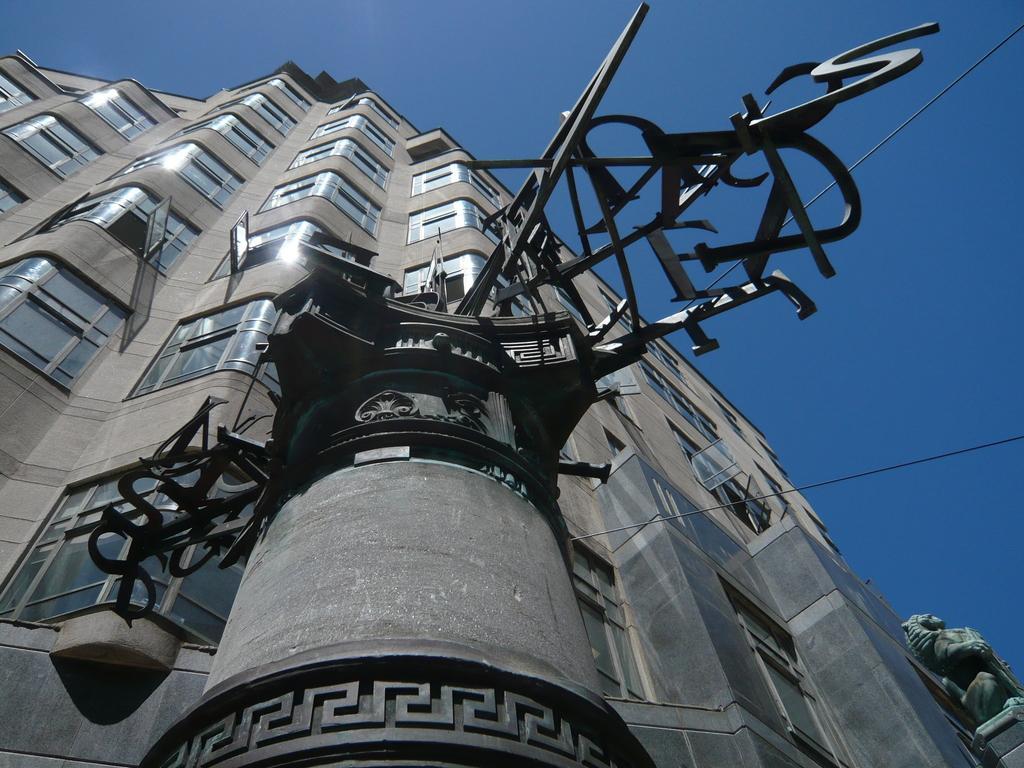Describe this image in one or two sentences. This picture is clicked outside. In the center there is an object and we can see the metal rods and the cables. On the right corner we can see the sculpture. On the left we can see the building and the windows of the building. In the background there is a sky. 